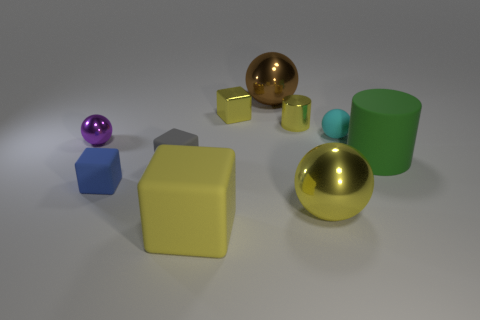Subtract 1 cubes. How many cubes are left? 3 Subtract all gray spheres. Subtract all yellow cylinders. How many spheres are left? 4 Subtract all blocks. How many objects are left? 6 Add 5 small yellow metal cubes. How many small yellow metal cubes are left? 6 Add 6 large brown metallic objects. How many large brown metallic objects exist? 7 Subtract 0 purple cubes. How many objects are left? 10 Subtract all gray blocks. Subtract all brown metal things. How many objects are left? 8 